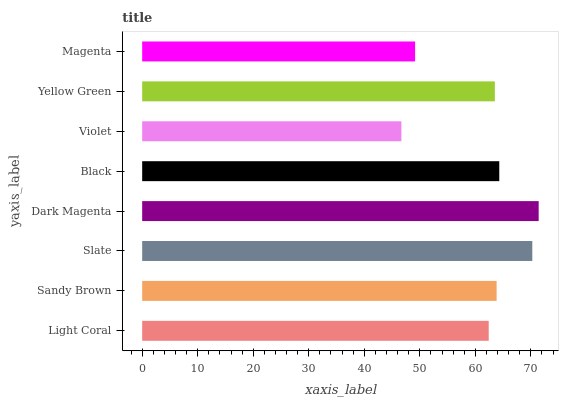Is Violet the minimum?
Answer yes or no. Yes. Is Dark Magenta the maximum?
Answer yes or no. Yes. Is Sandy Brown the minimum?
Answer yes or no. No. Is Sandy Brown the maximum?
Answer yes or no. No. Is Sandy Brown greater than Light Coral?
Answer yes or no. Yes. Is Light Coral less than Sandy Brown?
Answer yes or no. Yes. Is Light Coral greater than Sandy Brown?
Answer yes or no. No. Is Sandy Brown less than Light Coral?
Answer yes or no. No. Is Sandy Brown the high median?
Answer yes or no. Yes. Is Yellow Green the low median?
Answer yes or no. Yes. Is Black the high median?
Answer yes or no. No. Is Black the low median?
Answer yes or no. No. 